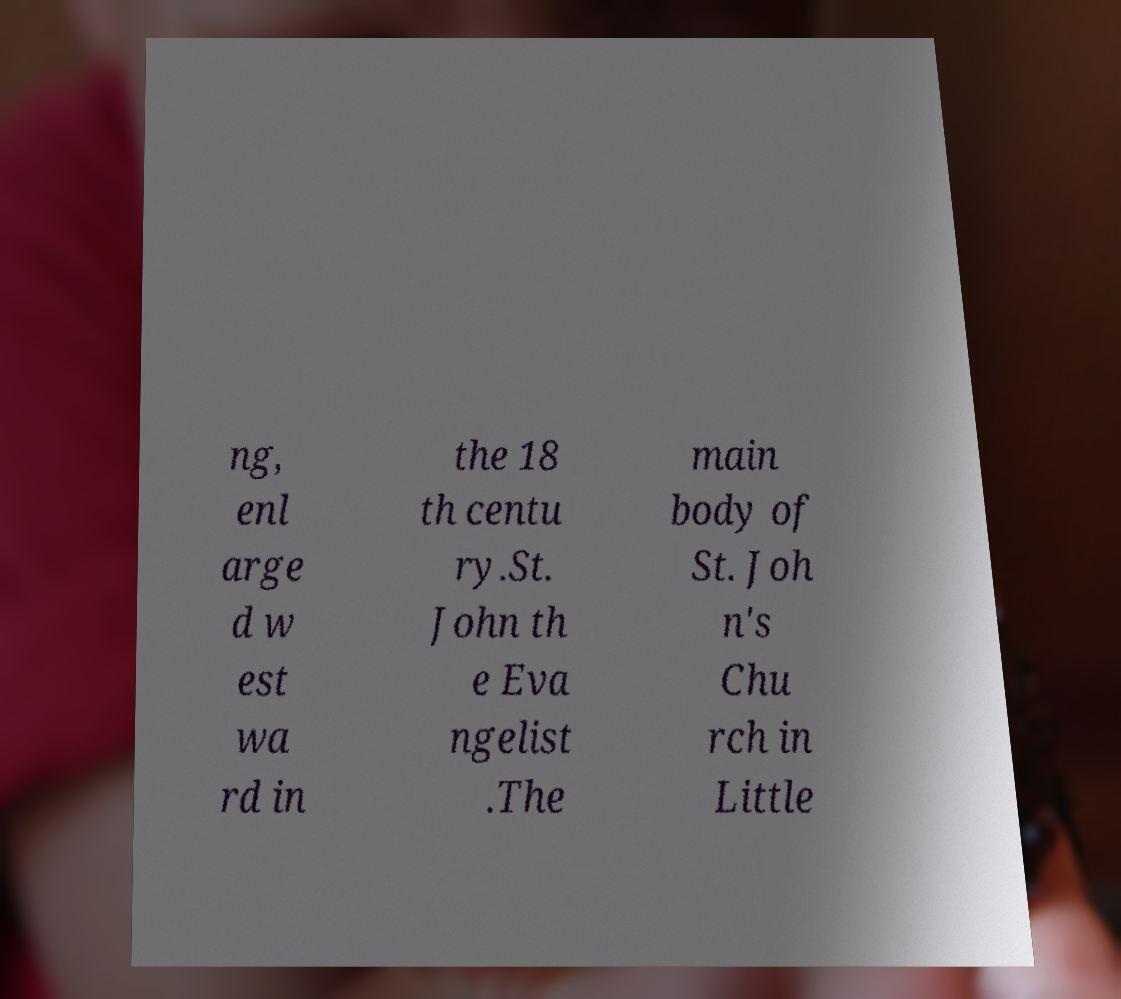Can you accurately transcribe the text from the provided image for me? ng, enl arge d w est wa rd in the 18 th centu ry.St. John th e Eva ngelist .The main body of St. Joh n's Chu rch in Little 